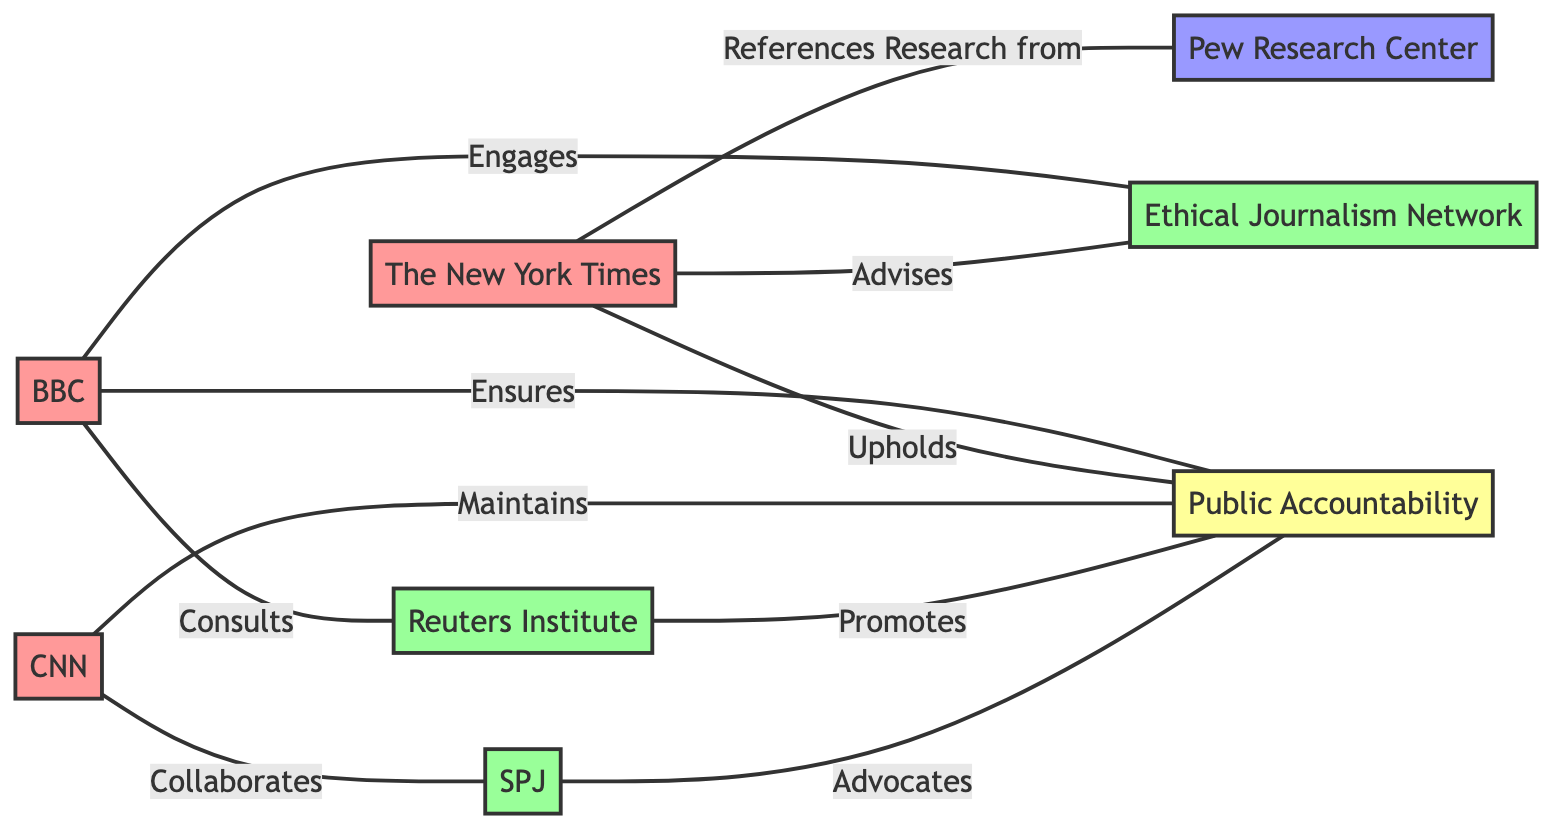What are the total number of nodes in the diagram? The diagram contains 8 nodes, which include various media companies, ethics advisory panels, a research organization, and a concept. Count each type shown in the diagram to verify this.
Answer: 8 Which media company collaborates with the Society of Professional Journalists? According to the edges in the diagram, CNN is linked to the Society of Professional Journalists with the relationship labeled "Collaborates." This is the information directly arising from the network connections to that specific panel.
Answer: CNN What relationship does the BBC have with the Reuters Institute for the Study of Journalism? The edge from BBC to the Reuters Institute for the Study of Journalism shows the relationship labeled "Consults," indicating that the BBC seeks guidance or advice from this ethics advisory panel.
Answer: Consults How many media companies engage with the Ethical Journalism Network? The diagram shows connections from BBC and The New York Times to the Ethical Journalism Network, indicating that there are two media companies engaging with this advisory panel. Each company is shown with a separate edge to the network.
Answer: 2 Which concept is promoted by the Ethics Advisory Panels? The edges indicate that both the Reuters Institute and the Society of Professional Journalists promote the concept of Public Accountability, as they both connect to it with respective labeled relationships.
Answer: Public Accountability What type of relationship does The New York Times have with Pew Research Center? The edge shows that The New York Times references research from Pew Research Center, providing insight into how media companies interact with research organizations. This specific relationship indicates a reliance on research findings.
Answer: References Research from How many total edges are present in the diagram? The diagram consists of 10 edges that depict the various relationships between the nodes. These include collaborations, consults, and references, which can be counted to determine the total number of interactions.
Answer: 10 What does the Society of Professional Journalists advocate for? The Society of Professional Journalists advocates for Public Accountability as indicated by the relationship labeled "Advocates" connecting to this specific concept node in the diagram. This shows the role of the panel in supporting accountability in journalism.
Answer: Public Accountability 